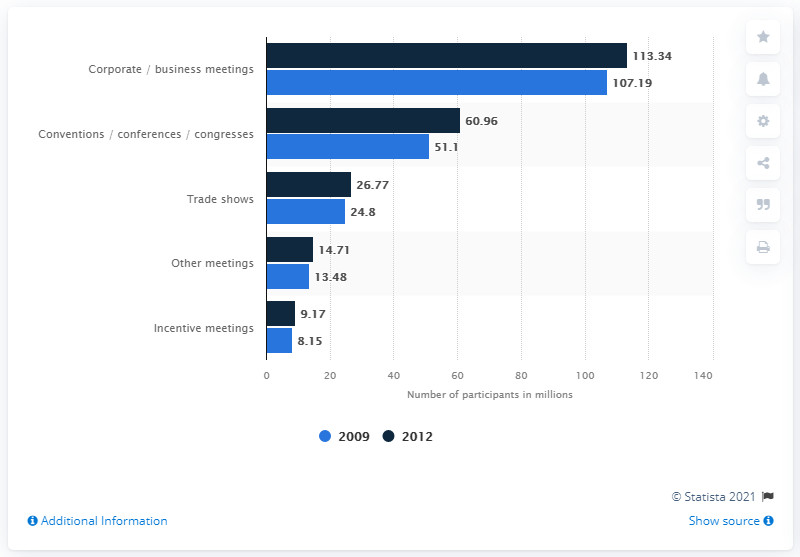Outline some significant characteristics in this image. Corporate/business meetings have the highest number of participants. In 2009, the average number of participants was 40.94. In 2009, the total number of people who participated in trade shows was 24.8 million. 